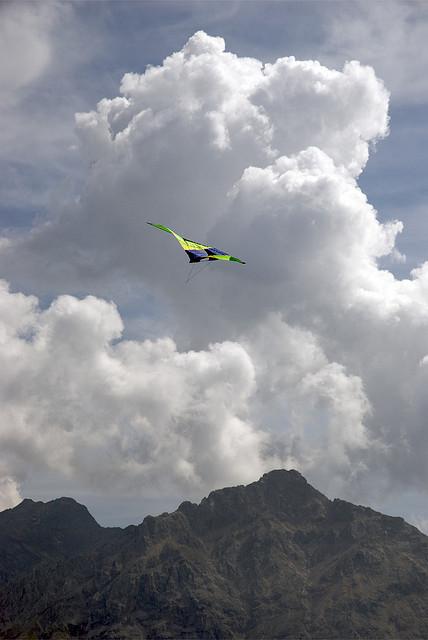What type of clouds are in the background?
Be succinct. Cumulus. How many kites are there?
Answer briefly. 1. Is there a bird in this photo?
Concise answer only. No. What is flying?
Give a very brief answer. Kite. 